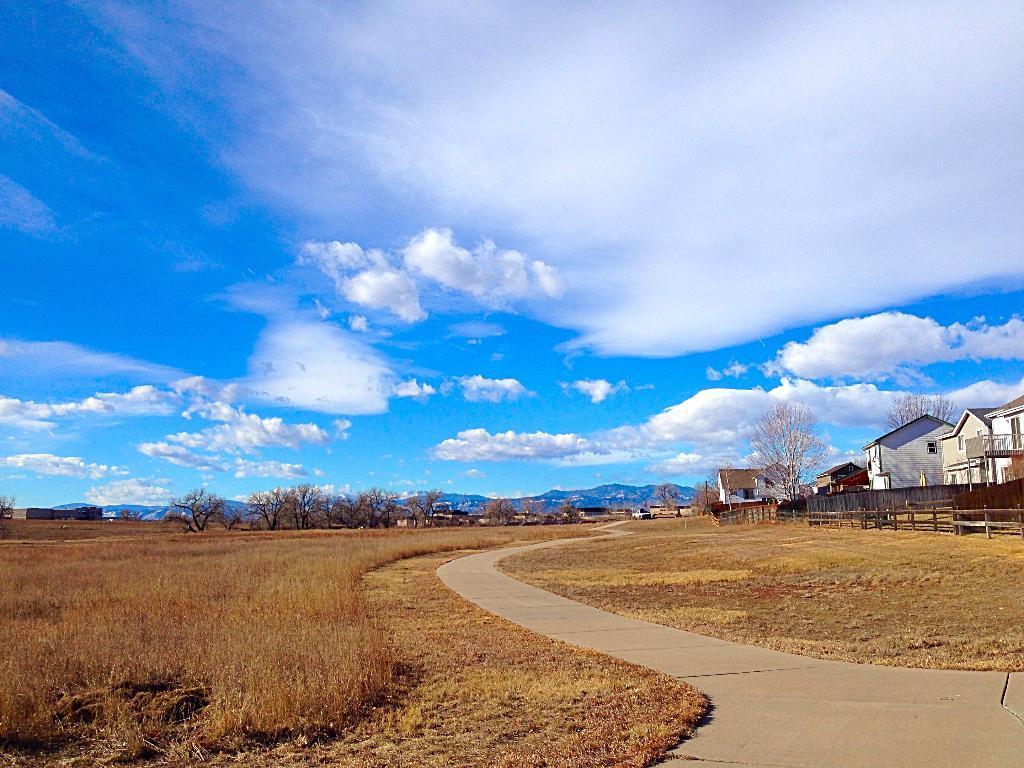What type of structures can be seen in the image? There are buildings in the image. What natural elements are present in the image? There are trees and a hill visible in the image. What type of vegetation can be seen in the image? Dry grass is visible in the image. What man-made features can be seen in the image? There is a road and a fence in the image. What is the condition of the sky in the image? The sky is cloudy in the image. Where is the queen sitting in the image? There is no queen present in the image. What type of fruit is being served in the lunchroom in the image? There is no lunchroom or fruit present in the image. 